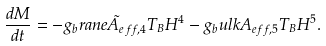<formula> <loc_0><loc_0><loc_500><loc_500>\frac { d M } { d t } = - g _ { b } r a n e \tilde { A } _ { e f f , 4 } T _ { B } H ^ { 4 } - g _ { b } u l k A _ { e f f , 5 } T _ { B } H ^ { 5 } .</formula> 